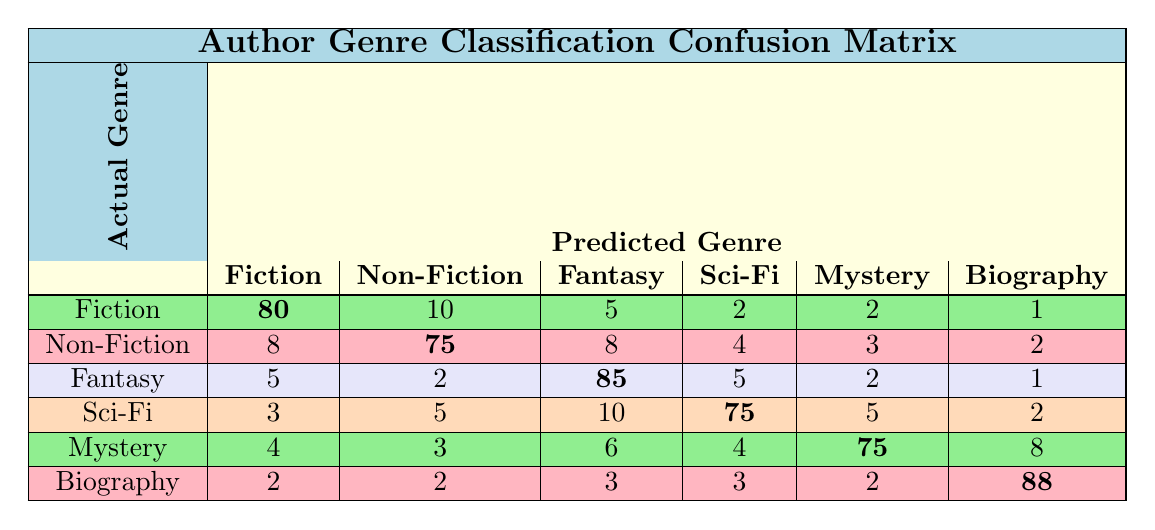What is the predicted value for the Non-Fiction genre classified as Non-Fiction? In the row for Non-Fiction and the column for Non-Fiction, the table indicates a value of 75.
Answer: 75 How many total predictions were made for the Fiction genre? To find the total predictions for Fiction, add all values in the Fiction row: 80 (Fiction) + 10 + 5 + 2 + 2 + 1 = 100.
Answer: 100 What is the accuracy rate for the Fantasy genre? The correct predictions for Fantasy (True Positives) is 85. To calculate accuracy, divide 85 by the total predictions for Fantasy (85 + 5 + 2 + 10 + 6 + 1 = 109) which gives 85/109 ≈ 0.7807, or approximately 78.07%.
Answer: 78.07% Were there more cases of Fiction predicted as Non-Fiction than Non-Fiction predicted as Fiction? The value for Fiction predicted as Non-Fiction is 10, while Non-Fiction predicted as Fiction is 8. Since 10 is greater than 8, it means there were indeed more Fiction cases predicted as Non-Fiction.
Answer: Yes What genre has the highest count of predicted values in the diagonal? The diagonal values are (80, 75, 85, 75, 75, 88) for the genres respectively. The highest value among these is 88, which corresponds to Biography.
Answer: Biography How many times was the Science Fiction genre incorrectly predicted as Fantasy? From the Science Fiction row, the value for Fantasy predictions is 10. This is the count of Science Fiction genre incorrectly classified as Fantasy.
Answer: 10 If we sum the predictions for Mystery across all genres, what is the total? For the Mystery genre, the predictions are: 2 (Fiction) + 3 (Non-Fiction) + 2 (Fantasy) + 4 (Sci-Fi) + 75 (Mystery) + 8 (Biography) = 94.
Answer: 94 What is the difference between the correct predictions for Biography and Fantasy? The correct predictions for Biography is 88, while for Fantasy it is 85. Therefore, the difference is 88 - 85 = 3.
Answer: 3 How many total predictions were incorrectly classified for the Sci-Fi genre? The incorrect predictions for Sci-Fi are the sum of the non-diagonal values in the Sci-Fi row: 3 + 5 + 10 + 5 + 2 = 25.
Answer: 25 